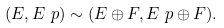<formula> <loc_0><loc_0><loc_500><loc_500>( E , E \ p ) \sim ( E \oplus F , E \ p \oplus F ) .</formula> 